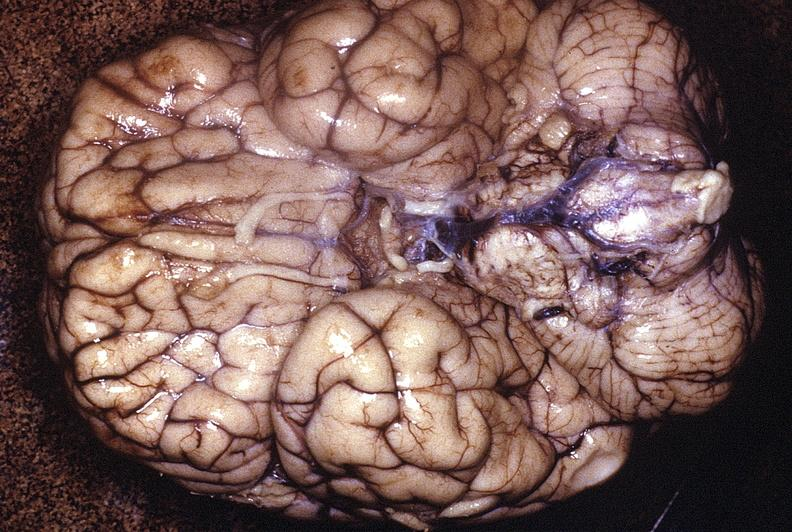s nervous present?
Answer the question using a single word or phrase. Yes 